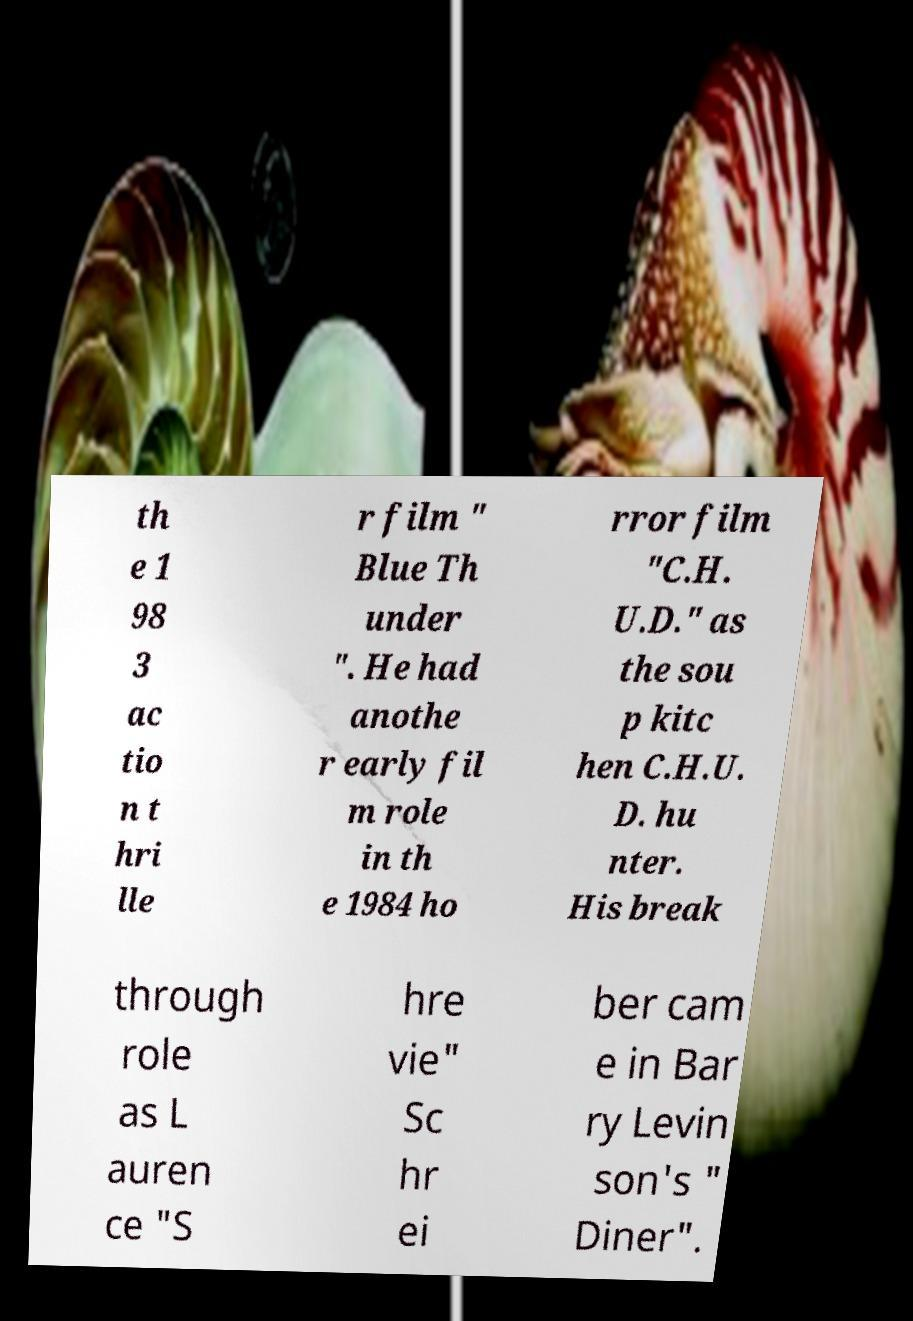Please identify and transcribe the text found in this image. th e 1 98 3 ac tio n t hri lle r film " Blue Th under ". He had anothe r early fil m role in th e 1984 ho rror film "C.H. U.D." as the sou p kitc hen C.H.U. D. hu nter. His break through role as L auren ce "S hre vie" Sc hr ei ber cam e in Bar ry Levin son's " Diner". 